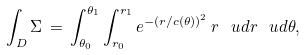<formula> <loc_0><loc_0><loc_500><loc_500>\int _ { D } \Sigma \, = \, \int _ { \theta _ { 0 } } ^ { \theta _ { 1 } } \int _ { r _ { 0 } } ^ { r _ { 1 } } e ^ { - ( r / c ( \theta ) ) ^ { 2 } } \, r \, \ u d r \, \ u d \theta ,</formula> 